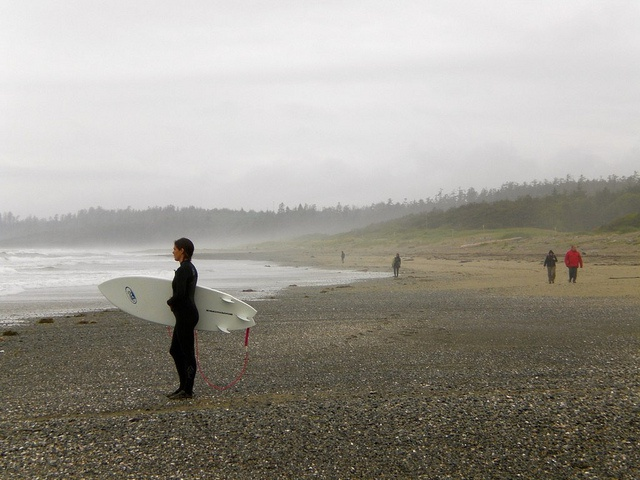Describe the objects in this image and their specific colors. I can see surfboard in white, darkgray, and gray tones, people in white, black, maroon, and gray tones, people in white, maroon, brown, and black tones, people in white, black, and gray tones, and people in white, gray, and black tones in this image. 